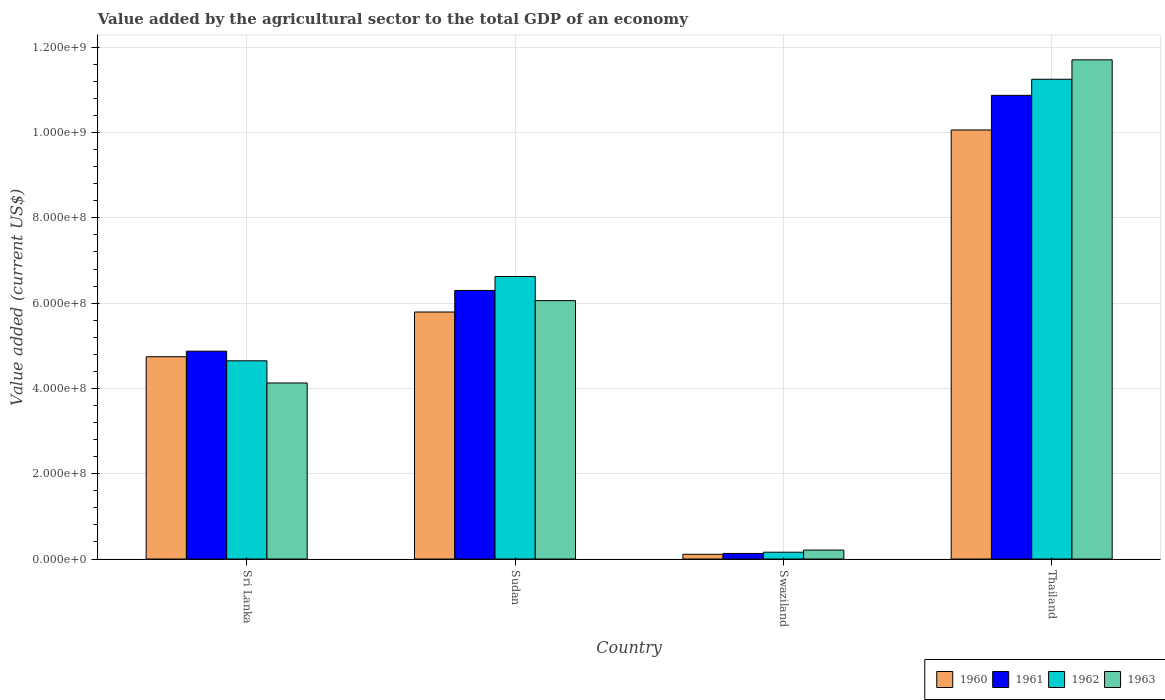How many groups of bars are there?
Give a very brief answer. 4. Are the number of bars on each tick of the X-axis equal?
Your response must be concise. Yes. What is the label of the 1st group of bars from the left?
Your answer should be very brief. Sri Lanka. In how many cases, is the number of bars for a given country not equal to the number of legend labels?
Offer a very short reply. 0. What is the value added by the agricultural sector to the total GDP in 1960 in Swaziland?
Offer a terse response. 1.11e+07. Across all countries, what is the maximum value added by the agricultural sector to the total GDP in 1960?
Provide a succinct answer. 1.01e+09. Across all countries, what is the minimum value added by the agricultural sector to the total GDP in 1960?
Keep it short and to the point. 1.11e+07. In which country was the value added by the agricultural sector to the total GDP in 1963 maximum?
Ensure brevity in your answer.  Thailand. In which country was the value added by the agricultural sector to the total GDP in 1961 minimum?
Give a very brief answer. Swaziland. What is the total value added by the agricultural sector to the total GDP in 1960 in the graph?
Your answer should be very brief. 2.07e+09. What is the difference between the value added by the agricultural sector to the total GDP in 1960 in Sudan and that in Thailand?
Offer a terse response. -4.27e+08. What is the difference between the value added by the agricultural sector to the total GDP in 1963 in Swaziland and the value added by the agricultural sector to the total GDP in 1960 in Sudan?
Offer a very short reply. -5.58e+08. What is the average value added by the agricultural sector to the total GDP in 1962 per country?
Keep it short and to the point. 5.67e+08. What is the difference between the value added by the agricultural sector to the total GDP of/in 1961 and value added by the agricultural sector to the total GDP of/in 1960 in Swaziland?
Keep it short and to the point. 1.96e+06. In how many countries, is the value added by the agricultural sector to the total GDP in 1961 greater than 80000000 US$?
Offer a terse response. 3. What is the ratio of the value added by the agricultural sector to the total GDP in 1963 in Sudan to that in Swaziland?
Provide a succinct answer. 28.86. Is the value added by the agricultural sector to the total GDP in 1961 in Sri Lanka less than that in Sudan?
Your answer should be compact. Yes. What is the difference between the highest and the second highest value added by the agricultural sector to the total GDP in 1962?
Keep it short and to the point. 6.60e+08. What is the difference between the highest and the lowest value added by the agricultural sector to the total GDP in 1960?
Offer a terse response. 9.95e+08. Is it the case that in every country, the sum of the value added by the agricultural sector to the total GDP in 1962 and value added by the agricultural sector to the total GDP in 1961 is greater than the sum of value added by the agricultural sector to the total GDP in 1963 and value added by the agricultural sector to the total GDP in 1960?
Your response must be concise. No. What does the 3rd bar from the left in Sudan represents?
Ensure brevity in your answer.  1962. Are all the bars in the graph horizontal?
Ensure brevity in your answer.  No. How many countries are there in the graph?
Provide a short and direct response. 4. Does the graph contain any zero values?
Make the answer very short. No. Does the graph contain grids?
Your answer should be compact. Yes. How are the legend labels stacked?
Offer a very short reply. Horizontal. What is the title of the graph?
Keep it short and to the point. Value added by the agricultural sector to the total GDP of an economy. What is the label or title of the X-axis?
Your answer should be very brief. Country. What is the label or title of the Y-axis?
Give a very brief answer. Value added (current US$). What is the Value added (current US$) of 1960 in Sri Lanka?
Ensure brevity in your answer.  4.74e+08. What is the Value added (current US$) of 1961 in Sri Lanka?
Provide a succinct answer. 4.87e+08. What is the Value added (current US$) of 1962 in Sri Lanka?
Provide a succinct answer. 4.65e+08. What is the Value added (current US$) of 1963 in Sri Lanka?
Provide a short and direct response. 4.13e+08. What is the Value added (current US$) of 1960 in Sudan?
Your response must be concise. 5.79e+08. What is the Value added (current US$) in 1961 in Sudan?
Offer a very short reply. 6.30e+08. What is the Value added (current US$) of 1962 in Sudan?
Offer a terse response. 6.63e+08. What is the Value added (current US$) of 1963 in Sudan?
Make the answer very short. 6.06e+08. What is the Value added (current US$) in 1960 in Swaziland?
Offer a terse response. 1.11e+07. What is the Value added (current US$) of 1961 in Swaziland?
Keep it short and to the point. 1.30e+07. What is the Value added (current US$) of 1962 in Swaziland?
Make the answer very short. 1.60e+07. What is the Value added (current US$) of 1963 in Swaziland?
Ensure brevity in your answer.  2.10e+07. What is the Value added (current US$) in 1960 in Thailand?
Keep it short and to the point. 1.01e+09. What is the Value added (current US$) of 1961 in Thailand?
Ensure brevity in your answer.  1.09e+09. What is the Value added (current US$) in 1962 in Thailand?
Ensure brevity in your answer.  1.13e+09. What is the Value added (current US$) of 1963 in Thailand?
Provide a short and direct response. 1.17e+09. Across all countries, what is the maximum Value added (current US$) in 1960?
Your response must be concise. 1.01e+09. Across all countries, what is the maximum Value added (current US$) in 1961?
Your answer should be compact. 1.09e+09. Across all countries, what is the maximum Value added (current US$) in 1962?
Keep it short and to the point. 1.13e+09. Across all countries, what is the maximum Value added (current US$) of 1963?
Keep it short and to the point. 1.17e+09. Across all countries, what is the minimum Value added (current US$) in 1960?
Provide a succinct answer. 1.11e+07. Across all countries, what is the minimum Value added (current US$) in 1961?
Make the answer very short. 1.30e+07. Across all countries, what is the minimum Value added (current US$) of 1962?
Offer a very short reply. 1.60e+07. Across all countries, what is the minimum Value added (current US$) in 1963?
Ensure brevity in your answer.  2.10e+07. What is the total Value added (current US$) in 1960 in the graph?
Ensure brevity in your answer.  2.07e+09. What is the total Value added (current US$) of 1961 in the graph?
Make the answer very short. 2.22e+09. What is the total Value added (current US$) of 1962 in the graph?
Provide a succinct answer. 2.27e+09. What is the total Value added (current US$) in 1963 in the graph?
Your response must be concise. 2.21e+09. What is the difference between the Value added (current US$) of 1960 in Sri Lanka and that in Sudan?
Your response must be concise. -1.05e+08. What is the difference between the Value added (current US$) of 1961 in Sri Lanka and that in Sudan?
Offer a very short reply. -1.42e+08. What is the difference between the Value added (current US$) in 1962 in Sri Lanka and that in Sudan?
Make the answer very short. -1.98e+08. What is the difference between the Value added (current US$) of 1963 in Sri Lanka and that in Sudan?
Offer a terse response. -1.93e+08. What is the difference between the Value added (current US$) in 1960 in Sri Lanka and that in Swaziland?
Provide a succinct answer. 4.63e+08. What is the difference between the Value added (current US$) of 1961 in Sri Lanka and that in Swaziland?
Your answer should be compact. 4.74e+08. What is the difference between the Value added (current US$) of 1962 in Sri Lanka and that in Swaziland?
Offer a terse response. 4.49e+08. What is the difference between the Value added (current US$) in 1963 in Sri Lanka and that in Swaziland?
Offer a very short reply. 3.92e+08. What is the difference between the Value added (current US$) in 1960 in Sri Lanka and that in Thailand?
Keep it short and to the point. -5.32e+08. What is the difference between the Value added (current US$) of 1961 in Sri Lanka and that in Thailand?
Ensure brevity in your answer.  -6.00e+08. What is the difference between the Value added (current US$) in 1962 in Sri Lanka and that in Thailand?
Your answer should be very brief. -6.60e+08. What is the difference between the Value added (current US$) of 1963 in Sri Lanka and that in Thailand?
Give a very brief answer. -7.58e+08. What is the difference between the Value added (current US$) of 1960 in Sudan and that in Swaziland?
Give a very brief answer. 5.68e+08. What is the difference between the Value added (current US$) of 1961 in Sudan and that in Swaziland?
Ensure brevity in your answer.  6.17e+08. What is the difference between the Value added (current US$) in 1962 in Sudan and that in Swaziland?
Offer a very short reply. 6.47e+08. What is the difference between the Value added (current US$) in 1963 in Sudan and that in Swaziland?
Keep it short and to the point. 5.85e+08. What is the difference between the Value added (current US$) of 1960 in Sudan and that in Thailand?
Make the answer very short. -4.27e+08. What is the difference between the Value added (current US$) of 1961 in Sudan and that in Thailand?
Your answer should be very brief. -4.58e+08. What is the difference between the Value added (current US$) of 1962 in Sudan and that in Thailand?
Provide a short and direct response. -4.63e+08. What is the difference between the Value added (current US$) in 1963 in Sudan and that in Thailand?
Your answer should be very brief. -5.65e+08. What is the difference between the Value added (current US$) of 1960 in Swaziland and that in Thailand?
Your answer should be compact. -9.95e+08. What is the difference between the Value added (current US$) of 1961 in Swaziland and that in Thailand?
Your response must be concise. -1.07e+09. What is the difference between the Value added (current US$) of 1962 in Swaziland and that in Thailand?
Offer a terse response. -1.11e+09. What is the difference between the Value added (current US$) of 1963 in Swaziland and that in Thailand?
Your answer should be compact. -1.15e+09. What is the difference between the Value added (current US$) of 1960 in Sri Lanka and the Value added (current US$) of 1961 in Sudan?
Keep it short and to the point. -1.55e+08. What is the difference between the Value added (current US$) in 1960 in Sri Lanka and the Value added (current US$) in 1962 in Sudan?
Offer a very short reply. -1.88e+08. What is the difference between the Value added (current US$) in 1960 in Sri Lanka and the Value added (current US$) in 1963 in Sudan?
Your response must be concise. -1.32e+08. What is the difference between the Value added (current US$) of 1961 in Sri Lanka and the Value added (current US$) of 1962 in Sudan?
Your response must be concise. -1.75e+08. What is the difference between the Value added (current US$) in 1961 in Sri Lanka and the Value added (current US$) in 1963 in Sudan?
Provide a succinct answer. -1.19e+08. What is the difference between the Value added (current US$) of 1962 in Sri Lanka and the Value added (current US$) of 1963 in Sudan?
Provide a short and direct response. -1.41e+08. What is the difference between the Value added (current US$) in 1960 in Sri Lanka and the Value added (current US$) in 1961 in Swaziland?
Provide a succinct answer. 4.61e+08. What is the difference between the Value added (current US$) of 1960 in Sri Lanka and the Value added (current US$) of 1962 in Swaziland?
Provide a succinct answer. 4.58e+08. What is the difference between the Value added (current US$) in 1960 in Sri Lanka and the Value added (current US$) in 1963 in Swaziland?
Provide a succinct answer. 4.53e+08. What is the difference between the Value added (current US$) in 1961 in Sri Lanka and the Value added (current US$) in 1962 in Swaziland?
Provide a succinct answer. 4.71e+08. What is the difference between the Value added (current US$) of 1961 in Sri Lanka and the Value added (current US$) of 1963 in Swaziland?
Your answer should be very brief. 4.66e+08. What is the difference between the Value added (current US$) of 1962 in Sri Lanka and the Value added (current US$) of 1963 in Swaziland?
Provide a succinct answer. 4.44e+08. What is the difference between the Value added (current US$) in 1960 in Sri Lanka and the Value added (current US$) in 1961 in Thailand?
Provide a short and direct response. -6.13e+08. What is the difference between the Value added (current US$) in 1960 in Sri Lanka and the Value added (current US$) in 1962 in Thailand?
Your response must be concise. -6.51e+08. What is the difference between the Value added (current US$) in 1960 in Sri Lanka and the Value added (current US$) in 1963 in Thailand?
Your answer should be very brief. -6.96e+08. What is the difference between the Value added (current US$) in 1961 in Sri Lanka and the Value added (current US$) in 1962 in Thailand?
Provide a short and direct response. -6.38e+08. What is the difference between the Value added (current US$) in 1961 in Sri Lanka and the Value added (current US$) in 1963 in Thailand?
Provide a succinct answer. -6.83e+08. What is the difference between the Value added (current US$) in 1962 in Sri Lanka and the Value added (current US$) in 1963 in Thailand?
Keep it short and to the point. -7.06e+08. What is the difference between the Value added (current US$) of 1960 in Sudan and the Value added (current US$) of 1961 in Swaziland?
Keep it short and to the point. 5.66e+08. What is the difference between the Value added (current US$) in 1960 in Sudan and the Value added (current US$) in 1962 in Swaziland?
Your answer should be very brief. 5.63e+08. What is the difference between the Value added (current US$) of 1960 in Sudan and the Value added (current US$) of 1963 in Swaziland?
Offer a terse response. 5.58e+08. What is the difference between the Value added (current US$) in 1961 in Sudan and the Value added (current US$) in 1962 in Swaziland?
Give a very brief answer. 6.14e+08. What is the difference between the Value added (current US$) of 1961 in Sudan and the Value added (current US$) of 1963 in Swaziland?
Your answer should be very brief. 6.09e+08. What is the difference between the Value added (current US$) in 1962 in Sudan and the Value added (current US$) in 1963 in Swaziland?
Your answer should be very brief. 6.42e+08. What is the difference between the Value added (current US$) in 1960 in Sudan and the Value added (current US$) in 1961 in Thailand?
Your answer should be compact. -5.08e+08. What is the difference between the Value added (current US$) in 1960 in Sudan and the Value added (current US$) in 1962 in Thailand?
Give a very brief answer. -5.46e+08. What is the difference between the Value added (current US$) in 1960 in Sudan and the Value added (current US$) in 1963 in Thailand?
Provide a succinct answer. -5.91e+08. What is the difference between the Value added (current US$) of 1961 in Sudan and the Value added (current US$) of 1962 in Thailand?
Your response must be concise. -4.95e+08. What is the difference between the Value added (current US$) in 1961 in Sudan and the Value added (current US$) in 1963 in Thailand?
Offer a very short reply. -5.41e+08. What is the difference between the Value added (current US$) in 1962 in Sudan and the Value added (current US$) in 1963 in Thailand?
Make the answer very short. -5.08e+08. What is the difference between the Value added (current US$) in 1960 in Swaziland and the Value added (current US$) in 1961 in Thailand?
Provide a short and direct response. -1.08e+09. What is the difference between the Value added (current US$) of 1960 in Swaziland and the Value added (current US$) of 1962 in Thailand?
Ensure brevity in your answer.  -1.11e+09. What is the difference between the Value added (current US$) in 1960 in Swaziland and the Value added (current US$) in 1963 in Thailand?
Ensure brevity in your answer.  -1.16e+09. What is the difference between the Value added (current US$) in 1961 in Swaziland and the Value added (current US$) in 1962 in Thailand?
Your answer should be compact. -1.11e+09. What is the difference between the Value added (current US$) in 1961 in Swaziland and the Value added (current US$) in 1963 in Thailand?
Your answer should be compact. -1.16e+09. What is the difference between the Value added (current US$) of 1962 in Swaziland and the Value added (current US$) of 1963 in Thailand?
Your answer should be compact. -1.15e+09. What is the average Value added (current US$) in 1960 per country?
Offer a terse response. 5.18e+08. What is the average Value added (current US$) of 1961 per country?
Offer a very short reply. 5.54e+08. What is the average Value added (current US$) in 1962 per country?
Provide a short and direct response. 5.67e+08. What is the average Value added (current US$) in 1963 per country?
Ensure brevity in your answer.  5.53e+08. What is the difference between the Value added (current US$) of 1960 and Value added (current US$) of 1961 in Sri Lanka?
Offer a very short reply. -1.30e+07. What is the difference between the Value added (current US$) in 1960 and Value added (current US$) in 1962 in Sri Lanka?
Ensure brevity in your answer.  9.55e+06. What is the difference between the Value added (current US$) of 1960 and Value added (current US$) of 1963 in Sri Lanka?
Provide a succinct answer. 6.16e+07. What is the difference between the Value added (current US$) in 1961 and Value added (current US$) in 1962 in Sri Lanka?
Make the answer very short. 2.26e+07. What is the difference between the Value added (current US$) in 1961 and Value added (current US$) in 1963 in Sri Lanka?
Ensure brevity in your answer.  7.46e+07. What is the difference between the Value added (current US$) of 1962 and Value added (current US$) of 1963 in Sri Lanka?
Offer a very short reply. 5.20e+07. What is the difference between the Value added (current US$) of 1960 and Value added (current US$) of 1961 in Sudan?
Keep it short and to the point. -5.05e+07. What is the difference between the Value added (current US$) of 1960 and Value added (current US$) of 1962 in Sudan?
Give a very brief answer. -8.33e+07. What is the difference between the Value added (current US$) in 1960 and Value added (current US$) in 1963 in Sudan?
Offer a very short reply. -2.67e+07. What is the difference between the Value added (current US$) of 1961 and Value added (current US$) of 1962 in Sudan?
Your answer should be compact. -3.27e+07. What is the difference between the Value added (current US$) in 1961 and Value added (current US$) in 1963 in Sudan?
Your answer should be very brief. 2.38e+07. What is the difference between the Value added (current US$) in 1962 and Value added (current US$) in 1963 in Sudan?
Ensure brevity in your answer.  5.66e+07. What is the difference between the Value added (current US$) of 1960 and Value added (current US$) of 1961 in Swaziland?
Provide a short and direct response. -1.96e+06. What is the difference between the Value added (current US$) of 1960 and Value added (current US$) of 1962 in Swaziland?
Provide a short and direct response. -4.90e+06. What is the difference between the Value added (current US$) in 1960 and Value added (current US$) in 1963 in Swaziland?
Your response must be concise. -9.94e+06. What is the difference between the Value added (current US$) of 1961 and Value added (current US$) of 1962 in Swaziland?
Your answer should be very brief. -2.94e+06. What is the difference between the Value added (current US$) in 1961 and Value added (current US$) in 1963 in Swaziland?
Provide a short and direct response. -7.98e+06. What is the difference between the Value added (current US$) of 1962 and Value added (current US$) of 1963 in Swaziland?
Offer a terse response. -5.04e+06. What is the difference between the Value added (current US$) of 1960 and Value added (current US$) of 1961 in Thailand?
Your answer should be compact. -8.12e+07. What is the difference between the Value added (current US$) in 1960 and Value added (current US$) in 1962 in Thailand?
Your answer should be compact. -1.19e+08. What is the difference between the Value added (current US$) of 1960 and Value added (current US$) of 1963 in Thailand?
Your answer should be very brief. -1.65e+08. What is the difference between the Value added (current US$) of 1961 and Value added (current US$) of 1962 in Thailand?
Ensure brevity in your answer.  -3.78e+07. What is the difference between the Value added (current US$) in 1961 and Value added (current US$) in 1963 in Thailand?
Ensure brevity in your answer.  -8.33e+07. What is the difference between the Value added (current US$) in 1962 and Value added (current US$) in 1963 in Thailand?
Ensure brevity in your answer.  -4.55e+07. What is the ratio of the Value added (current US$) of 1960 in Sri Lanka to that in Sudan?
Offer a very short reply. 0.82. What is the ratio of the Value added (current US$) of 1961 in Sri Lanka to that in Sudan?
Your answer should be compact. 0.77. What is the ratio of the Value added (current US$) in 1962 in Sri Lanka to that in Sudan?
Offer a terse response. 0.7. What is the ratio of the Value added (current US$) in 1963 in Sri Lanka to that in Sudan?
Provide a succinct answer. 0.68. What is the ratio of the Value added (current US$) in 1960 in Sri Lanka to that in Swaziland?
Offer a terse response. 42.89. What is the ratio of the Value added (current US$) of 1961 in Sri Lanka to that in Swaziland?
Your response must be concise. 37.43. What is the ratio of the Value added (current US$) in 1962 in Sri Lanka to that in Swaziland?
Your answer should be compact. 29.12. What is the ratio of the Value added (current US$) of 1963 in Sri Lanka to that in Swaziland?
Make the answer very short. 19.66. What is the ratio of the Value added (current US$) of 1960 in Sri Lanka to that in Thailand?
Your answer should be very brief. 0.47. What is the ratio of the Value added (current US$) in 1961 in Sri Lanka to that in Thailand?
Ensure brevity in your answer.  0.45. What is the ratio of the Value added (current US$) of 1962 in Sri Lanka to that in Thailand?
Ensure brevity in your answer.  0.41. What is the ratio of the Value added (current US$) in 1963 in Sri Lanka to that in Thailand?
Provide a short and direct response. 0.35. What is the ratio of the Value added (current US$) of 1960 in Sudan to that in Swaziland?
Make the answer very short. 52.37. What is the ratio of the Value added (current US$) of 1961 in Sudan to that in Swaziland?
Your answer should be compact. 48.37. What is the ratio of the Value added (current US$) in 1962 in Sudan to that in Swaziland?
Give a very brief answer. 41.51. What is the ratio of the Value added (current US$) of 1963 in Sudan to that in Swaziland?
Make the answer very short. 28.86. What is the ratio of the Value added (current US$) of 1960 in Sudan to that in Thailand?
Give a very brief answer. 0.58. What is the ratio of the Value added (current US$) of 1961 in Sudan to that in Thailand?
Your answer should be compact. 0.58. What is the ratio of the Value added (current US$) of 1962 in Sudan to that in Thailand?
Ensure brevity in your answer.  0.59. What is the ratio of the Value added (current US$) in 1963 in Sudan to that in Thailand?
Provide a short and direct response. 0.52. What is the ratio of the Value added (current US$) of 1960 in Swaziland to that in Thailand?
Keep it short and to the point. 0.01. What is the ratio of the Value added (current US$) in 1961 in Swaziland to that in Thailand?
Give a very brief answer. 0.01. What is the ratio of the Value added (current US$) of 1962 in Swaziland to that in Thailand?
Keep it short and to the point. 0.01. What is the ratio of the Value added (current US$) in 1963 in Swaziland to that in Thailand?
Give a very brief answer. 0.02. What is the difference between the highest and the second highest Value added (current US$) of 1960?
Provide a short and direct response. 4.27e+08. What is the difference between the highest and the second highest Value added (current US$) in 1961?
Your answer should be compact. 4.58e+08. What is the difference between the highest and the second highest Value added (current US$) in 1962?
Your answer should be compact. 4.63e+08. What is the difference between the highest and the second highest Value added (current US$) of 1963?
Your response must be concise. 5.65e+08. What is the difference between the highest and the lowest Value added (current US$) in 1960?
Offer a very short reply. 9.95e+08. What is the difference between the highest and the lowest Value added (current US$) of 1961?
Keep it short and to the point. 1.07e+09. What is the difference between the highest and the lowest Value added (current US$) of 1962?
Ensure brevity in your answer.  1.11e+09. What is the difference between the highest and the lowest Value added (current US$) of 1963?
Keep it short and to the point. 1.15e+09. 